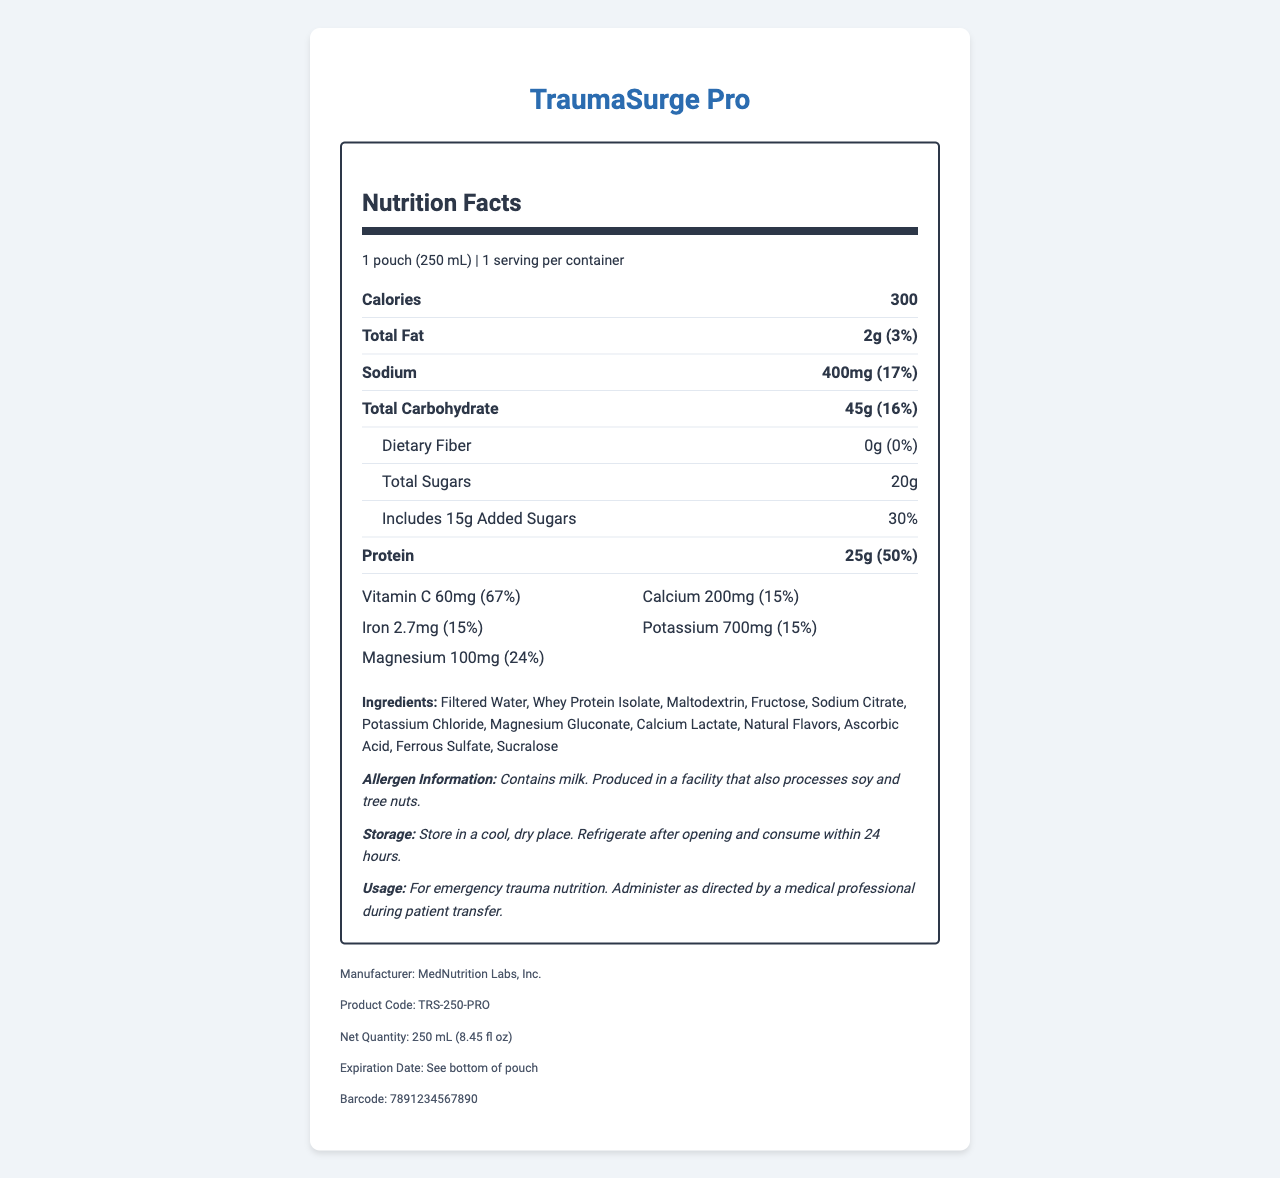what is the serving size of TraumaSurge Pro? The serving size is clearly stated in the document as "1 pouch (250 mL)".
Answer: 1 pouch (250 mL) how many calories does one serving contain? The document lists the caloric content as "300" under the nutrition facts.
Answer: 300 what is the amount of total fat per serving? The total fat content is specified as "2g" in the nutrition facts section.
Answer: 2g what percentage of daily value does the sodium content represent? Under the sodium entry, the daily value percentage is indicated as "17%".
Answer: 17% how much protein is in each serving? The amount of protein per serving is clearly noted as "25g" in the document.
Answer: 25g which of the following vitamins or minerals has the highest daily value percentage? A. Vitamin C B. Calcium C. Iron D. Potassium Vitamin C has a daily value percentage of "67%", which is higher than Calcium (15%), Iron (15%), Potassium (15%), and Magnesium (24%).
Answer: A. Vitamin C the product contains a significant amount of which macronutrient? A. Carbohydrates B. Protein C. Fat The protein content is 25g with a daily value of 50%, indicating a high protein content relative to total carbohydrates (45g, 16%) and fat (2g, 3%).
Answer: B. Protein is TraumaSurge Pro safe for someone with a milk allergy? The allergen information states that the product contains milk.
Answer: No summarize the main information provided in the document. The summary includes all critical information regarding the product's nutritional content, usage, storage, manufacturer details, and safety information.
Answer: The document provides nutrition facts for TraumaSurge Pro, an emergency trauma nutrition supplement. It details serving size, caloric content, amounts of macronutrients (fat, carbohydrates, protein), vitamins and minerals, ingredients, allergen information, storage and usage instructions, manufacturer details, product code, net quantity, expiration date, and barcode. can this product replace a meal? The document provides detailed nutritional information but does not specify whether it is intended as a meal replacement.
Answer: Cannot be determined what is the total amount of sugars, including added sugars, in one serving? The document lists "Total Sugars" as 20g, which includes added sugars.
Answer: 20g are there any dietary fibers in the product? The dietary fiber content is listed as 0g in the nutrition facts.
Answer: No what purpose is TraumaSurge Pro intended to serve? The usage instructions clearly state that it is for emergency trauma nutrition during patient transfer.
Answer: Emergency trauma nutrition how much potassium is in each serving? The amount of potassium per serving is listed as 700mg in the vitamins and minerals section.
Answer: 700mg which ingredient is used as a sweetener in TraumaSurge Pro? The ingredient list includes Sucralose, which is a common artificial sweetener.
Answer: Sucralose does the product need refrigeration after opening? The storage instructions specify that it should be refrigerated after opening and consumed within 24 hours.
Answer: Yes 